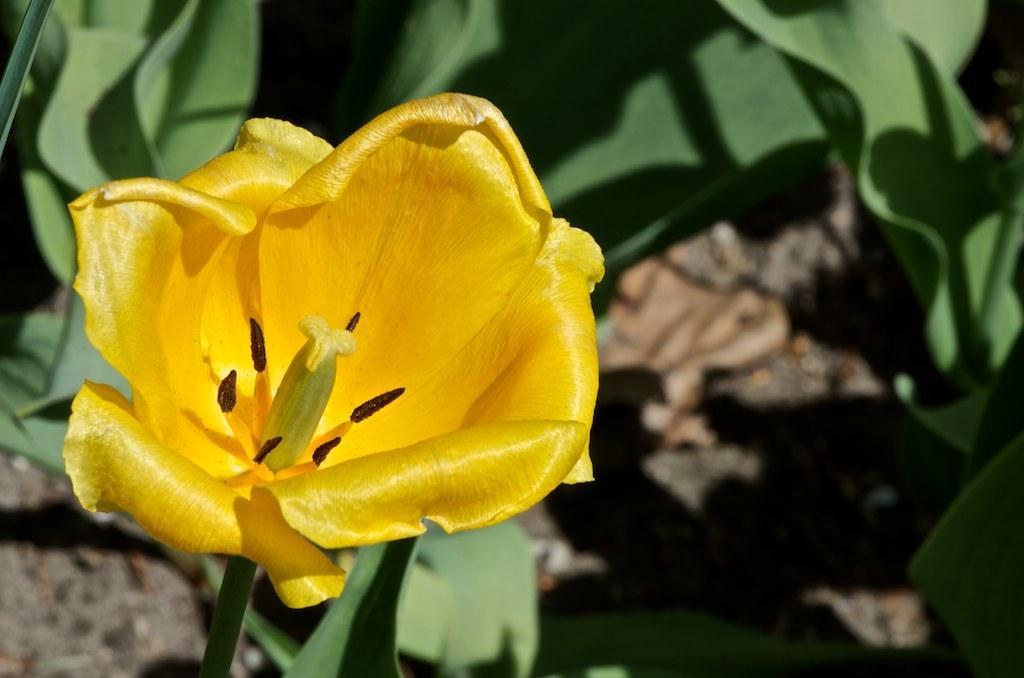In one or two sentences, can you explain what this image depicts? In this image there is a flower, behind the flower there are leaves. 